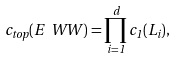<formula> <loc_0><loc_0><loc_500><loc_500>c _ { t o p } ( E _ { \ } W W ) = \prod _ { i = 1 } ^ { d } c _ { 1 } ( L _ { i } ) ,</formula> 